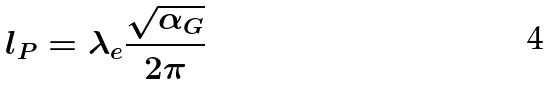<formula> <loc_0><loc_0><loc_500><loc_500>l _ { P } = \lambda _ { e } \frac { \sqrt { \alpha _ { G } } } { 2 \pi }</formula> 